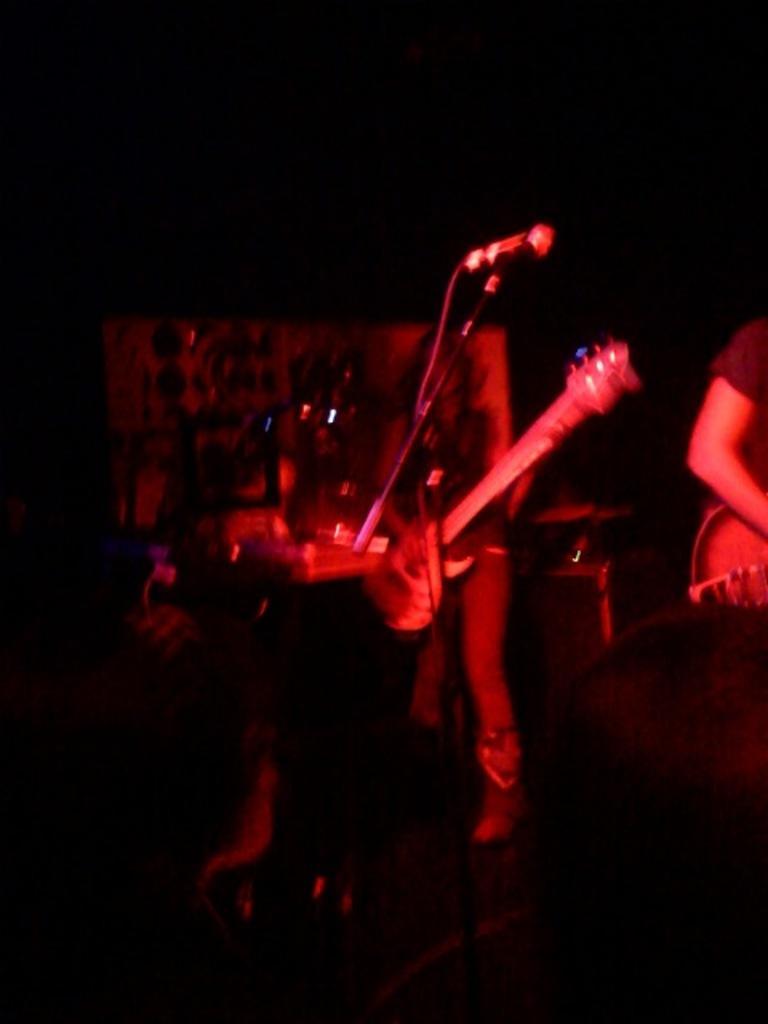In one or two sentences, can you explain what this image depicts? In this image I can see a person standing and holding a guitar in hands and I can see a microphone. To the right side of the image I can see another person holding the guitar. I can see the black colored background. 